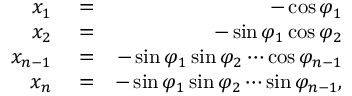Convert formula to latex. <formula><loc_0><loc_0><loc_500><loc_500>\begin{array} { r l r } { x _ { 1 } } & = } & { - \cos \varphi _ { 1 } } \\ { x _ { 2 } } & = } & { - \sin \varphi _ { 1 } \cos \varphi _ { 2 } } \\ { x _ { n - 1 } } & = } & { - \sin \varphi _ { 1 } \sin \varphi _ { 2 } \cdots \cos \varphi _ { n - 1 } } \\ { x _ { n } } & = } & { - \sin \varphi _ { 1 } \sin \varphi _ { 2 } \cdots \sin \varphi _ { n - 1 } , } \end{array}</formula> 